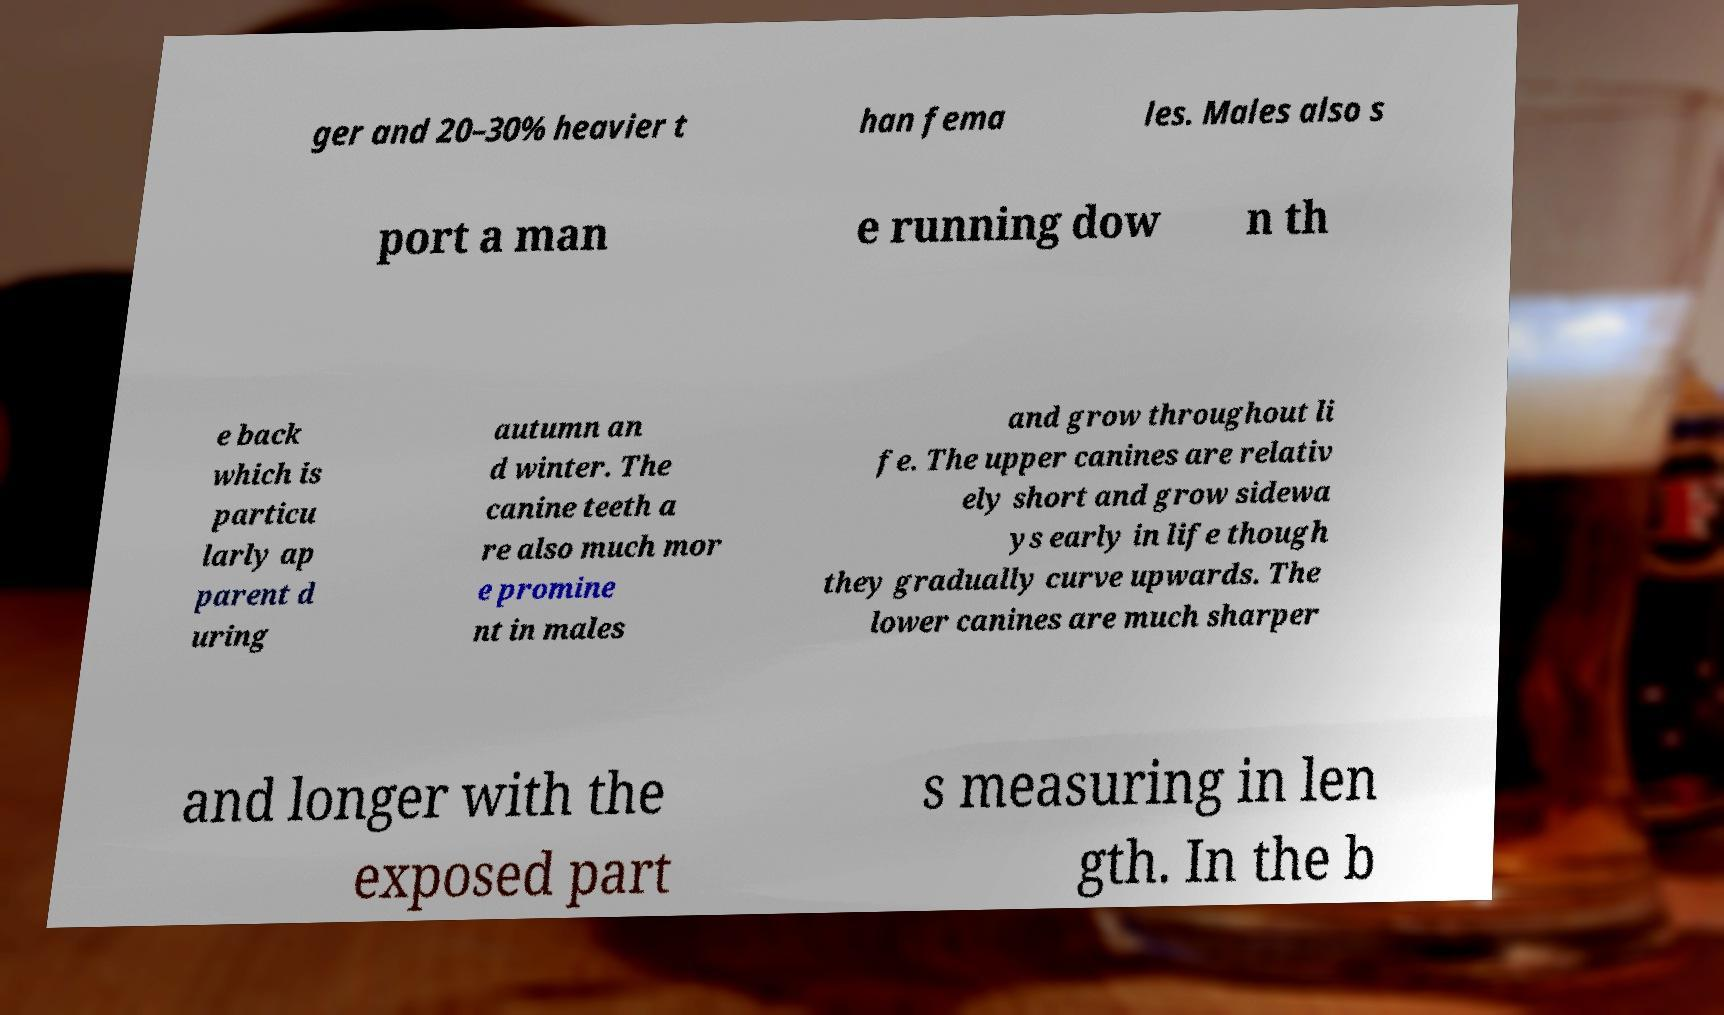Can you read and provide the text displayed in the image?This photo seems to have some interesting text. Can you extract and type it out for me? ger and 20–30% heavier t han fema les. Males also s port a man e running dow n th e back which is particu larly ap parent d uring autumn an d winter. The canine teeth a re also much mor e promine nt in males and grow throughout li fe. The upper canines are relativ ely short and grow sidewa ys early in life though they gradually curve upwards. The lower canines are much sharper and longer with the exposed part s measuring in len gth. In the b 